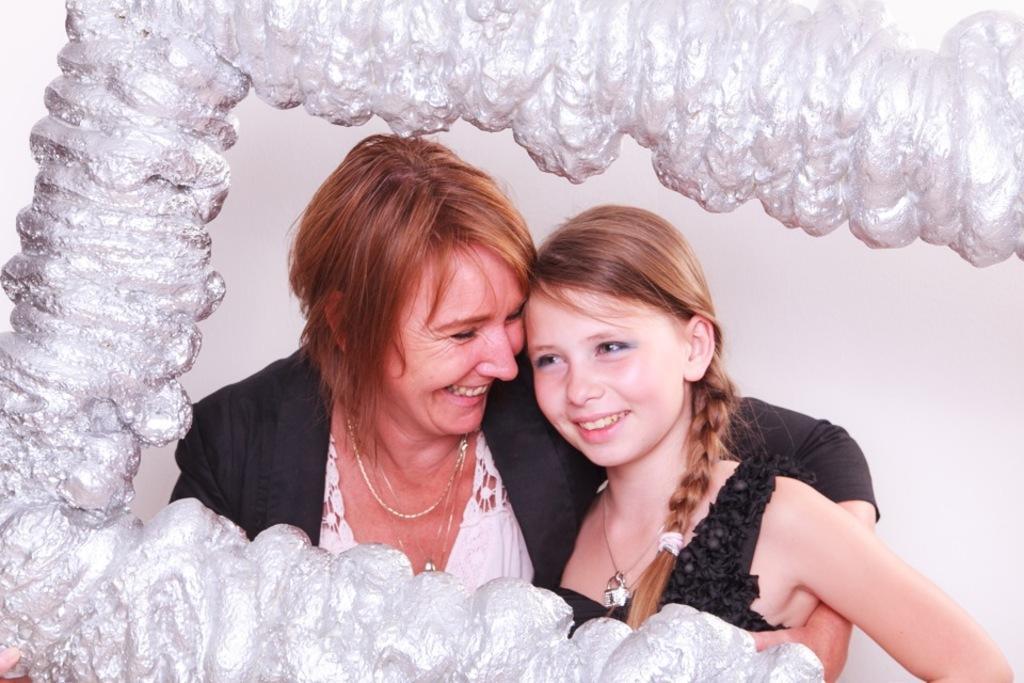In one or two sentences, can you explain what this image depicts? In this image I can see a woman and girl and they both are smiling wearing black color dress and around them I can see yarn fiber. 